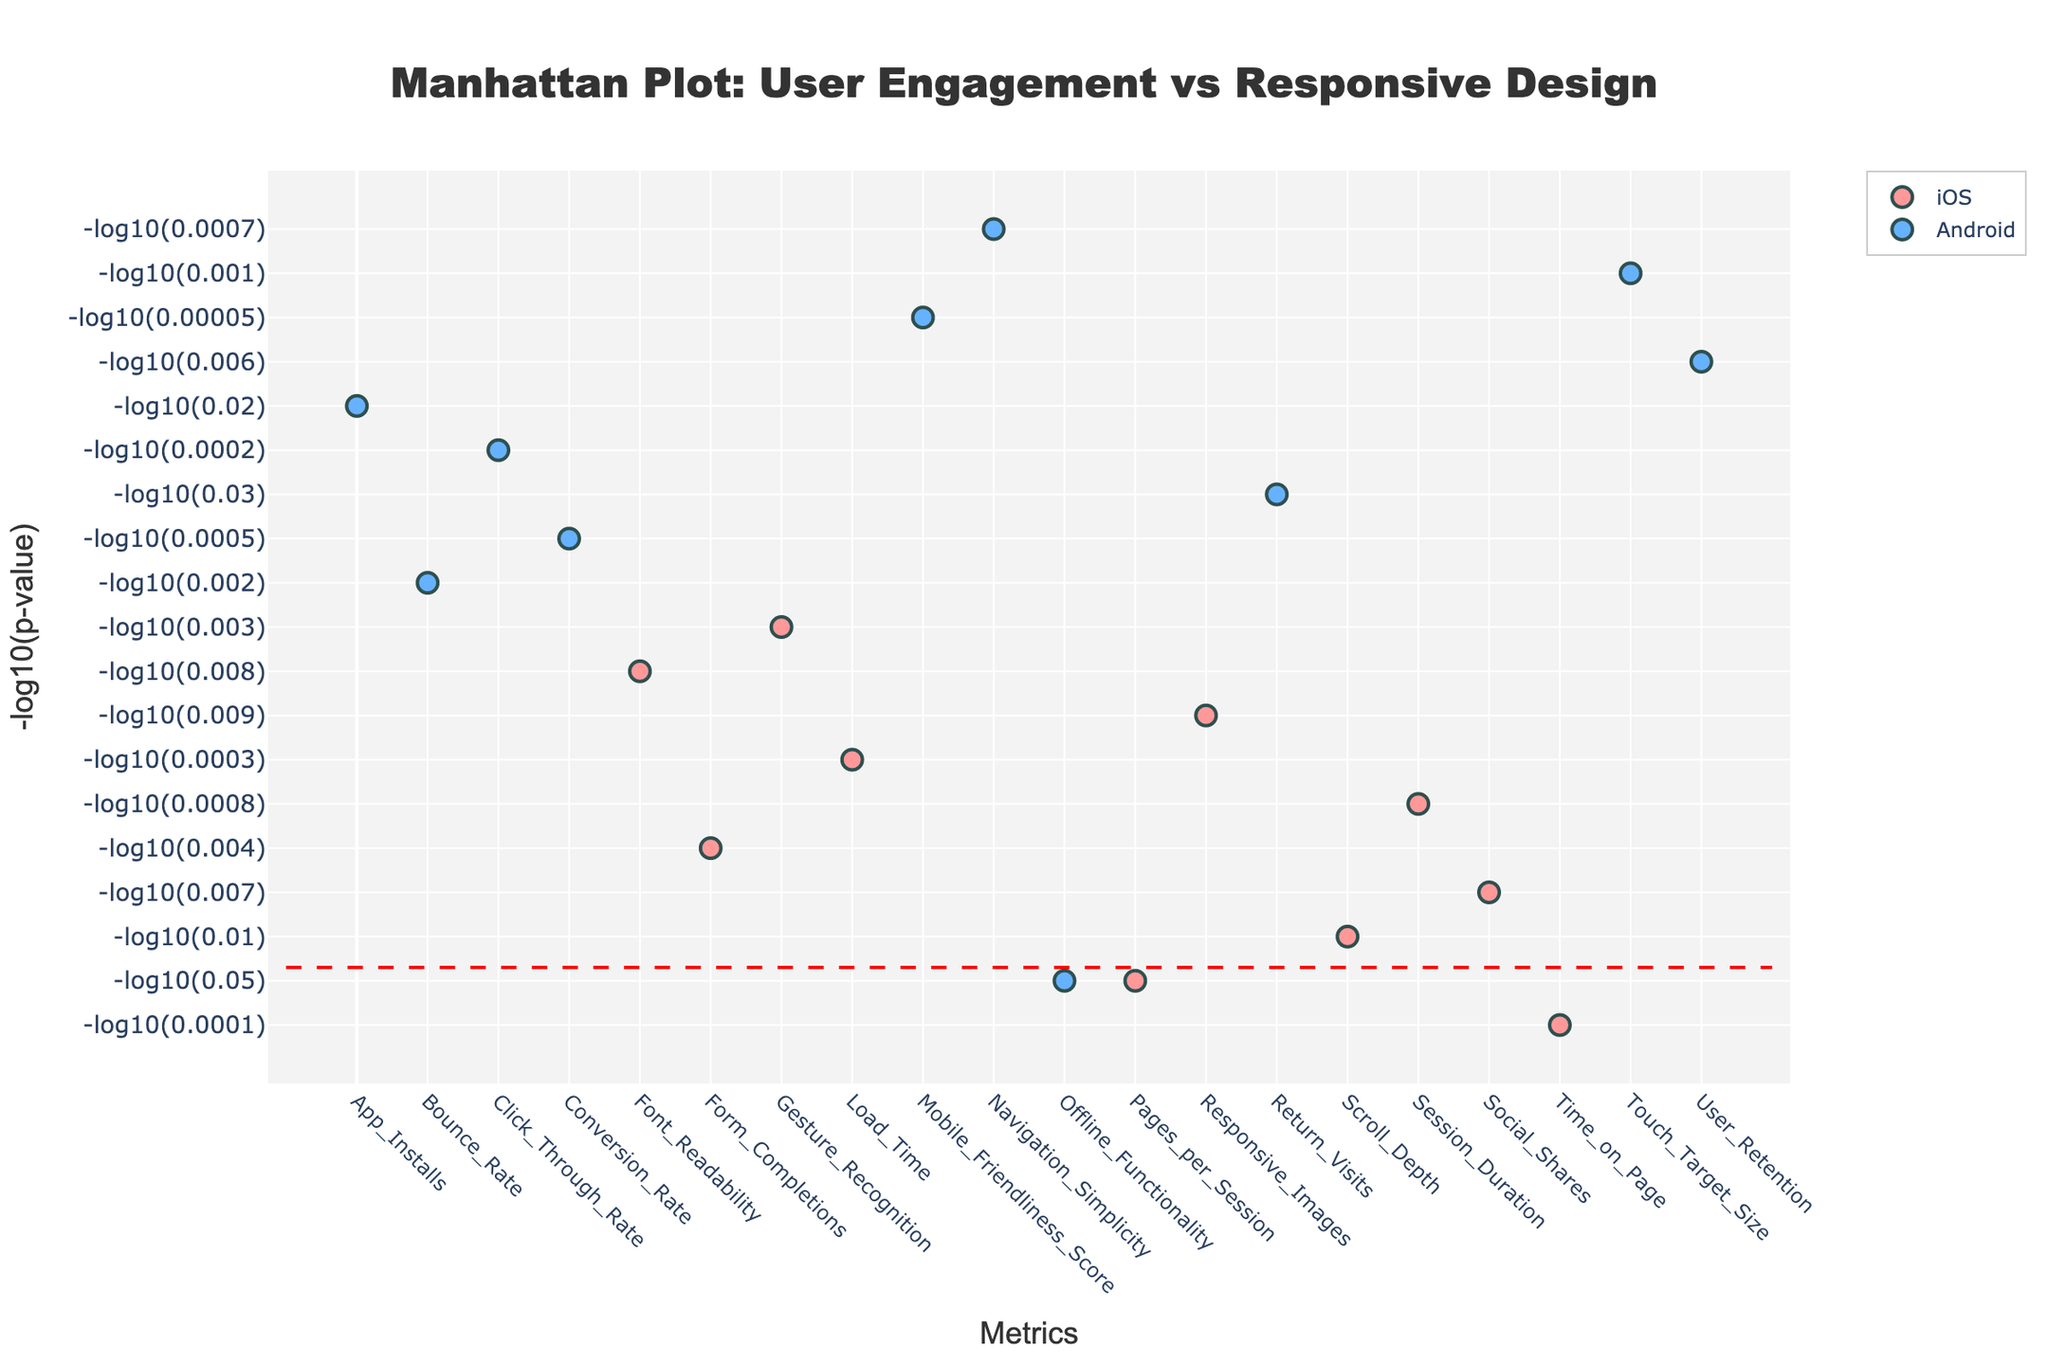What is the title of the plot? The title is typically located at the top center of the plot. By reading this title, we understand the plot's focus: 'Manhattan Plot: User Engagement vs Responsive Design'.
Answer: Manhattan Plot: User Engagement vs Responsive Design How many metrics are shown in the plot? The x-axis shows individual metrics related to user engagement. Counting all unique tick marks on the x-axis gives us the number of metrics.
Answer: 20 What is the y-axis title? The y-axis usually indicates the measure being analyzed or plotted. Here, the label shows the negative logarithm of p-values for each metric.
Answer: -log10(p-value) Which platform has the highest -log10(p-value) metric? Examine the tallest points (since the y-axis represents -log10(p-value)) and identify their corresponding platforms using the plot legend and hover text. The metric with the highest value appears for the metric with the smallest original p-value.
Answer: iOS Which metric under the Android platform has the lowest significance? For Android, find the point with the lowest y-axis value, which corresponds to the highest p-value.
Answer: Offline Functionality How many metrics are above the significance line (-log10(0.05)) on the iOS platform? Count the number of points above the horizontal red dashed significance line (-log10(0.05)) that are colored in the iOS-specific color (e.g., pink).
Answer: 7 What is the significance threshold line in terms of p-value? The horizontal line's position can be converted back to a p-value using the -log10 transformation. Here the line represents -log10(0.05).
Answer: 0.05 Which metric on the iOS platform has a -log10(p-value) of approximately 4? Locate the high points around y=4 for iOS, then hover to reveal the metric name.
Answer: Time on Page What is the difference in metrics count between iOS and Android platforms above the significance threshold? First, count the number of metrics for both platforms above the significance line, then subtract the counts (for straightforward, iOS minus Android).
Answer: 1 more for iOS Between "Conversion Rate" on Android and "Session Duration" on iOS, which has a lower -log10(p-value), hence lower significance? Compare their positions on the y-axis to see which one is lower; the lower one has the higher p-value or lower significance.
Answer: Session Duration on iOS 